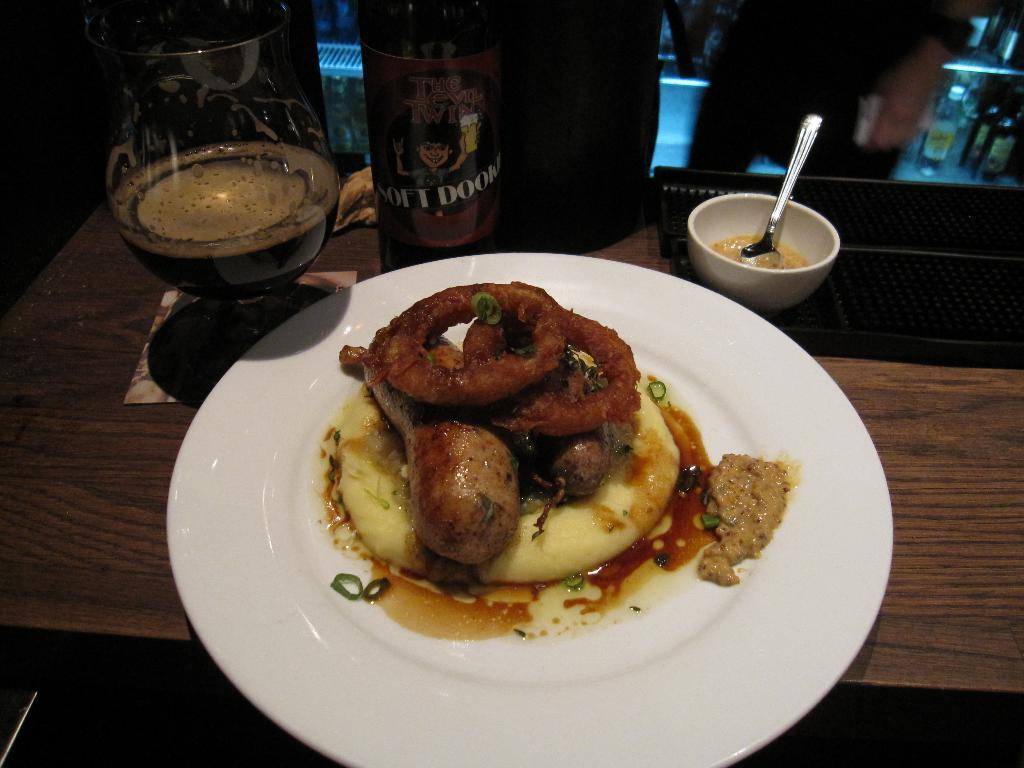What is on the plate in the image? There is food served on a plate in the image. What can be seen in the background of the image? There is a beer bottle in the backdrop of the image. Who is present near the table in the image? There are people standing near the table in the image. Can you tell me how many pears are on the plate in the image? There is no pear present on the plate in the image; it only contains food. What type of fruit is the zebra holding in the image? There is no zebra present in the image, so it cannot be holding any fruit. 